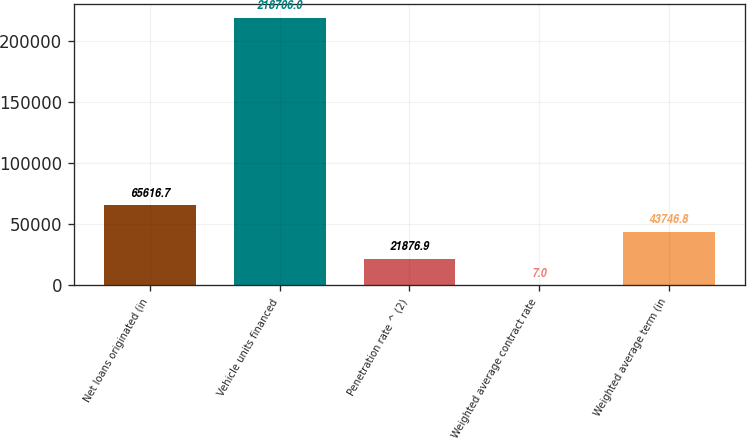Convert chart to OTSL. <chart><loc_0><loc_0><loc_500><loc_500><bar_chart><fcel>Net loans originated (in<fcel>Vehicle units financed<fcel>Penetration rate ^ (2)<fcel>Weighted average contract rate<fcel>Weighted average term (in<nl><fcel>65616.7<fcel>218706<fcel>21876.9<fcel>7<fcel>43746.8<nl></chart> 